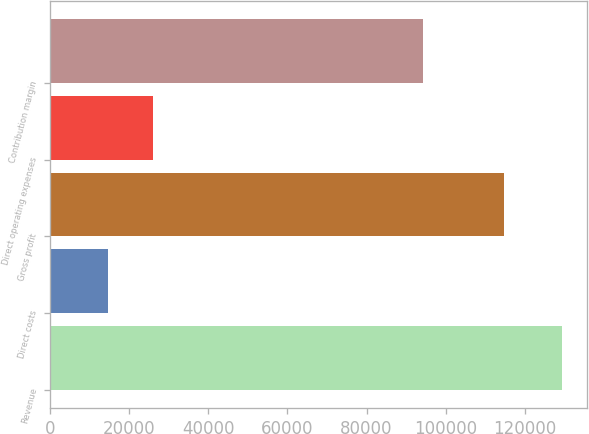Convert chart to OTSL. <chart><loc_0><loc_0><loc_500><loc_500><bar_chart><fcel>Revenue<fcel>Direct costs<fcel>Gross profit<fcel>Direct operating expenses<fcel>Contribution margin<nl><fcel>129333<fcel>14533<fcel>114800<fcel>26013<fcel>94279<nl></chart> 